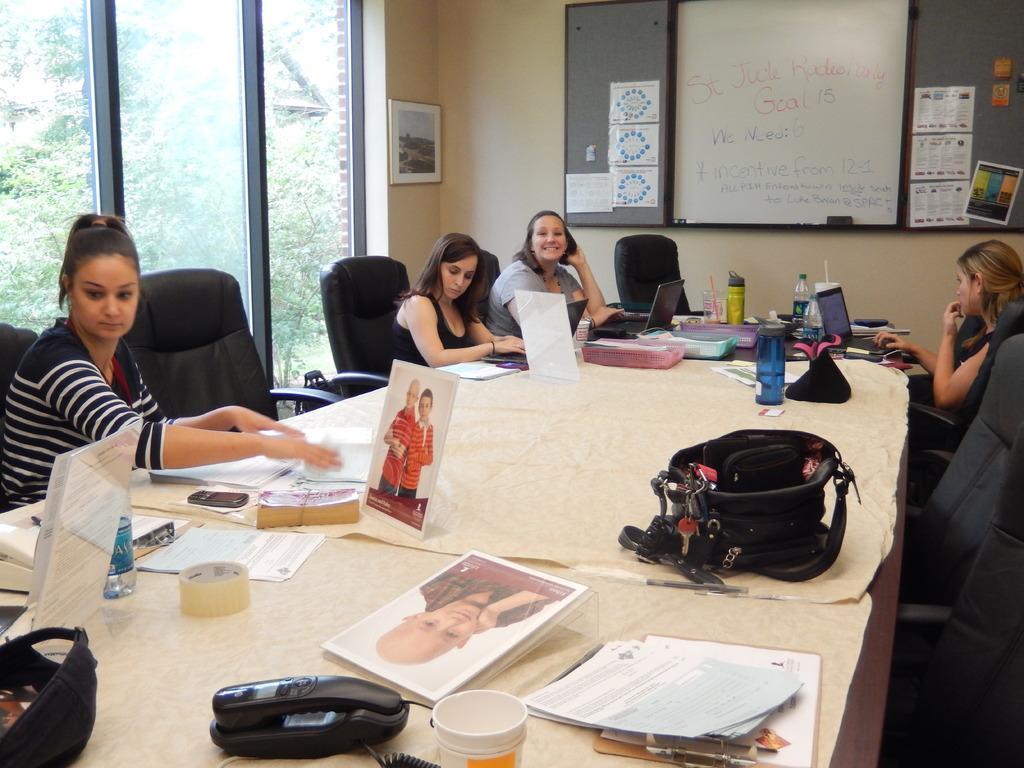How would you summarize this image in a sentence or two? The image inside the room. In the image group of people are sitting on chair in front of a table, on table we can see a cloth,bottle,board,paper,land mobile. On left side there is a glass door which is closed in background there is a white color board and a wall which is in cream color and a photo frame attached to a cream color wall. 